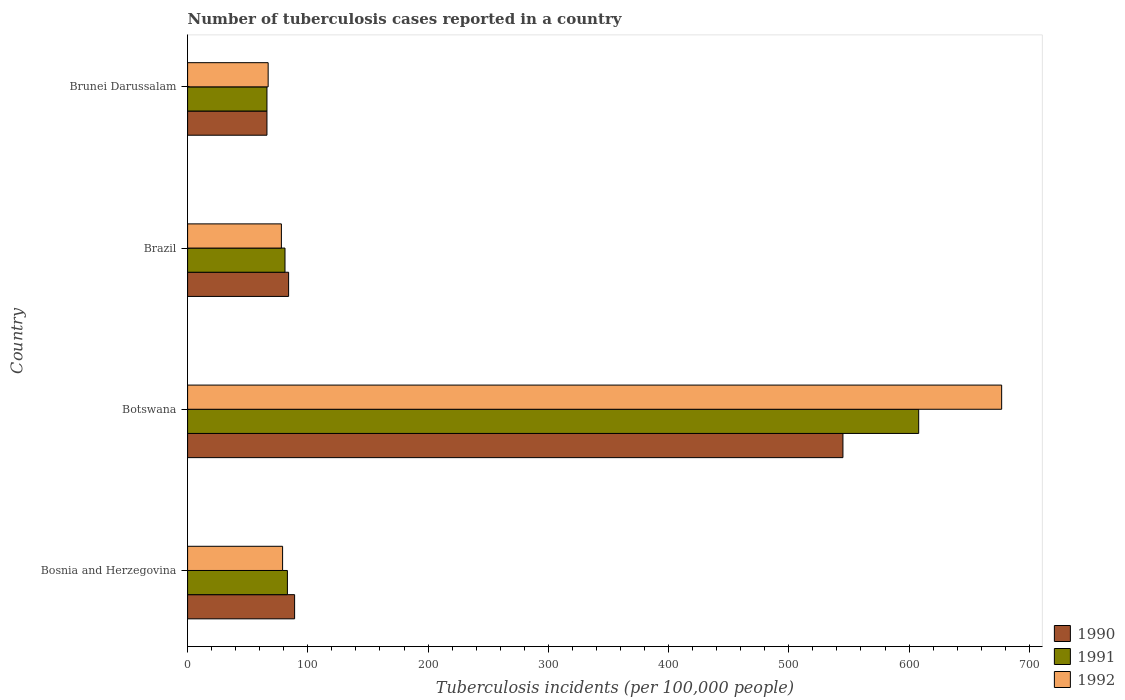How many different coloured bars are there?
Ensure brevity in your answer.  3. How many groups of bars are there?
Your answer should be compact. 4. Are the number of bars per tick equal to the number of legend labels?
Your response must be concise. Yes. Are the number of bars on each tick of the Y-axis equal?
Offer a very short reply. Yes. How many bars are there on the 1st tick from the top?
Offer a very short reply. 3. How many bars are there on the 4th tick from the bottom?
Your response must be concise. 3. What is the label of the 2nd group of bars from the top?
Provide a short and direct response. Brazil. What is the number of tuberculosis cases reported in in 1990 in Botswana?
Your response must be concise. 545. Across all countries, what is the maximum number of tuberculosis cases reported in in 1992?
Ensure brevity in your answer.  677. Across all countries, what is the minimum number of tuberculosis cases reported in in 1990?
Provide a short and direct response. 66. In which country was the number of tuberculosis cases reported in in 1992 maximum?
Your answer should be compact. Botswana. In which country was the number of tuberculosis cases reported in in 1991 minimum?
Your response must be concise. Brunei Darussalam. What is the total number of tuberculosis cases reported in in 1990 in the graph?
Give a very brief answer. 784. What is the average number of tuberculosis cases reported in in 1991 per country?
Provide a succinct answer. 209.5. What is the ratio of the number of tuberculosis cases reported in in 1990 in Botswana to that in Brazil?
Make the answer very short. 6.49. Is the number of tuberculosis cases reported in in 1992 in Bosnia and Herzegovina less than that in Brunei Darussalam?
Your answer should be very brief. No. What is the difference between the highest and the second highest number of tuberculosis cases reported in in 1992?
Ensure brevity in your answer.  598. What is the difference between the highest and the lowest number of tuberculosis cases reported in in 1992?
Keep it short and to the point. 610. What does the 1st bar from the top in Botswana represents?
Provide a short and direct response. 1992. What does the 1st bar from the bottom in Brazil represents?
Your answer should be very brief. 1990. Is it the case that in every country, the sum of the number of tuberculosis cases reported in in 1991 and number of tuberculosis cases reported in in 1990 is greater than the number of tuberculosis cases reported in in 1992?
Make the answer very short. Yes. Are all the bars in the graph horizontal?
Your response must be concise. Yes. How many countries are there in the graph?
Your answer should be compact. 4. Are the values on the major ticks of X-axis written in scientific E-notation?
Offer a terse response. No. Does the graph contain grids?
Provide a short and direct response. No. Where does the legend appear in the graph?
Give a very brief answer. Bottom right. How many legend labels are there?
Provide a succinct answer. 3. What is the title of the graph?
Your answer should be compact. Number of tuberculosis cases reported in a country. What is the label or title of the X-axis?
Ensure brevity in your answer.  Tuberculosis incidents (per 100,0 people). What is the Tuberculosis incidents (per 100,000 people) in 1990 in Bosnia and Herzegovina?
Offer a very short reply. 89. What is the Tuberculosis incidents (per 100,000 people) of 1992 in Bosnia and Herzegovina?
Ensure brevity in your answer.  79. What is the Tuberculosis incidents (per 100,000 people) of 1990 in Botswana?
Make the answer very short. 545. What is the Tuberculosis incidents (per 100,000 people) in 1991 in Botswana?
Your answer should be compact. 608. What is the Tuberculosis incidents (per 100,000 people) in 1992 in Botswana?
Ensure brevity in your answer.  677. What is the Tuberculosis incidents (per 100,000 people) of 1990 in Brazil?
Ensure brevity in your answer.  84. What is the Tuberculosis incidents (per 100,000 people) in 1991 in Brazil?
Offer a terse response. 81. What is the Tuberculosis incidents (per 100,000 people) in 1992 in Brazil?
Your response must be concise. 78. What is the Tuberculosis incidents (per 100,000 people) in 1992 in Brunei Darussalam?
Give a very brief answer. 67. Across all countries, what is the maximum Tuberculosis incidents (per 100,000 people) of 1990?
Keep it short and to the point. 545. Across all countries, what is the maximum Tuberculosis incidents (per 100,000 people) in 1991?
Make the answer very short. 608. Across all countries, what is the maximum Tuberculosis incidents (per 100,000 people) of 1992?
Keep it short and to the point. 677. Across all countries, what is the minimum Tuberculosis incidents (per 100,000 people) of 1990?
Give a very brief answer. 66. Across all countries, what is the minimum Tuberculosis incidents (per 100,000 people) of 1992?
Provide a short and direct response. 67. What is the total Tuberculosis incidents (per 100,000 people) in 1990 in the graph?
Your answer should be compact. 784. What is the total Tuberculosis incidents (per 100,000 people) in 1991 in the graph?
Your response must be concise. 838. What is the total Tuberculosis incidents (per 100,000 people) in 1992 in the graph?
Keep it short and to the point. 901. What is the difference between the Tuberculosis incidents (per 100,000 people) in 1990 in Bosnia and Herzegovina and that in Botswana?
Your answer should be compact. -456. What is the difference between the Tuberculosis incidents (per 100,000 people) of 1991 in Bosnia and Herzegovina and that in Botswana?
Provide a succinct answer. -525. What is the difference between the Tuberculosis incidents (per 100,000 people) in 1992 in Bosnia and Herzegovina and that in Botswana?
Offer a terse response. -598. What is the difference between the Tuberculosis incidents (per 100,000 people) of 1990 in Bosnia and Herzegovina and that in Brazil?
Make the answer very short. 5. What is the difference between the Tuberculosis incidents (per 100,000 people) of 1991 in Bosnia and Herzegovina and that in Brazil?
Provide a succinct answer. 2. What is the difference between the Tuberculosis incidents (per 100,000 people) in 1992 in Bosnia and Herzegovina and that in Brazil?
Offer a very short reply. 1. What is the difference between the Tuberculosis incidents (per 100,000 people) in 1990 in Bosnia and Herzegovina and that in Brunei Darussalam?
Offer a very short reply. 23. What is the difference between the Tuberculosis incidents (per 100,000 people) of 1991 in Bosnia and Herzegovina and that in Brunei Darussalam?
Provide a short and direct response. 17. What is the difference between the Tuberculosis incidents (per 100,000 people) of 1992 in Bosnia and Herzegovina and that in Brunei Darussalam?
Provide a short and direct response. 12. What is the difference between the Tuberculosis incidents (per 100,000 people) in 1990 in Botswana and that in Brazil?
Provide a short and direct response. 461. What is the difference between the Tuberculosis incidents (per 100,000 people) in 1991 in Botswana and that in Brazil?
Provide a short and direct response. 527. What is the difference between the Tuberculosis incidents (per 100,000 people) of 1992 in Botswana and that in Brazil?
Your answer should be compact. 599. What is the difference between the Tuberculosis incidents (per 100,000 people) in 1990 in Botswana and that in Brunei Darussalam?
Your answer should be very brief. 479. What is the difference between the Tuberculosis incidents (per 100,000 people) of 1991 in Botswana and that in Brunei Darussalam?
Your response must be concise. 542. What is the difference between the Tuberculosis incidents (per 100,000 people) of 1992 in Botswana and that in Brunei Darussalam?
Make the answer very short. 610. What is the difference between the Tuberculosis incidents (per 100,000 people) of 1990 in Brazil and that in Brunei Darussalam?
Your answer should be compact. 18. What is the difference between the Tuberculosis incidents (per 100,000 people) in 1991 in Brazil and that in Brunei Darussalam?
Your answer should be very brief. 15. What is the difference between the Tuberculosis incidents (per 100,000 people) in 1990 in Bosnia and Herzegovina and the Tuberculosis incidents (per 100,000 people) in 1991 in Botswana?
Provide a succinct answer. -519. What is the difference between the Tuberculosis incidents (per 100,000 people) of 1990 in Bosnia and Herzegovina and the Tuberculosis incidents (per 100,000 people) of 1992 in Botswana?
Make the answer very short. -588. What is the difference between the Tuberculosis incidents (per 100,000 people) of 1991 in Bosnia and Herzegovina and the Tuberculosis incidents (per 100,000 people) of 1992 in Botswana?
Make the answer very short. -594. What is the difference between the Tuberculosis incidents (per 100,000 people) in 1991 in Bosnia and Herzegovina and the Tuberculosis incidents (per 100,000 people) in 1992 in Brazil?
Make the answer very short. 5. What is the difference between the Tuberculosis incidents (per 100,000 people) in 1990 in Bosnia and Herzegovina and the Tuberculosis incidents (per 100,000 people) in 1991 in Brunei Darussalam?
Make the answer very short. 23. What is the difference between the Tuberculosis incidents (per 100,000 people) of 1990 in Bosnia and Herzegovina and the Tuberculosis incidents (per 100,000 people) of 1992 in Brunei Darussalam?
Your answer should be compact. 22. What is the difference between the Tuberculosis incidents (per 100,000 people) of 1990 in Botswana and the Tuberculosis incidents (per 100,000 people) of 1991 in Brazil?
Offer a terse response. 464. What is the difference between the Tuberculosis incidents (per 100,000 people) of 1990 in Botswana and the Tuberculosis incidents (per 100,000 people) of 1992 in Brazil?
Your answer should be very brief. 467. What is the difference between the Tuberculosis incidents (per 100,000 people) of 1991 in Botswana and the Tuberculosis incidents (per 100,000 people) of 1992 in Brazil?
Keep it short and to the point. 530. What is the difference between the Tuberculosis incidents (per 100,000 people) in 1990 in Botswana and the Tuberculosis incidents (per 100,000 people) in 1991 in Brunei Darussalam?
Your response must be concise. 479. What is the difference between the Tuberculosis incidents (per 100,000 people) in 1990 in Botswana and the Tuberculosis incidents (per 100,000 people) in 1992 in Brunei Darussalam?
Keep it short and to the point. 478. What is the difference between the Tuberculosis incidents (per 100,000 people) in 1991 in Botswana and the Tuberculosis incidents (per 100,000 people) in 1992 in Brunei Darussalam?
Your response must be concise. 541. What is the difference between the Tuberculosis incidents (per 100,000 people) in 1990 in Brazil and the Tuberculosis incidents (per 100,000 people) in 1992 in Brunei Darussalam?
Your answer should be very brief. 17. What is the difference between the Tuberculosis incidents (per 100,000 people) in 1991 in Brazil and the Tuberculosis incidents (per 100,000 people) in 1992 in Brunei Darussalam?
Make the answer very short. 14. What is the average Tuberculosis incidents (per 100,000 people) of 1990 per country?
Your answer should be compact. 196. What is the average Tuberculosis incidents (per 100,000 people) of 1991 per country?
Provide a succinct answer. 209.5. What is the average Tuberculosis incidents (per 100,000 people) of 1992 per country?
Your response must be concise. 225.25. What is the difference between the Tuberculosis incidents (per 100,000 people) of 1990 and Tuberculosis incidents (per 100,000 people) of 1991 in Bosnia and Herzegovina?
Give a very brief answer. 6. What is the difference between the Tuberculosis incidents (per 100,000 people) in 1990 and Tuberculosis incidents (per 100,000 people) in 1992 in Bosnia and Herzegovina?
Provide a succinct answer. 10. What is the difference between the Tuberculosis incidents (per 100,000 people) in 1991 and Tuberculosis incidents (per 100,000 people) in 1992 in Bosnia and Herzegovina?
Your answer should be very brief. 4. What is the difference between the Tuberculosis incidents (per 100,000 people) in 1990 and Tuberculosis incidents (per 100,000 people) in 1991 in Botswana?
Offer a very short reply. -63. What is the difference between the Tuberculosis incidents (per 100,000 people) in 1990 and Tuberculosis incidents (per 100,000 people) in 1992 in Botswana?
Keep it short and to the point. -132. What is the difference between the Tuberculosis incidents (per 100,000 people) in 1991 and Tuberculosis incidents (per 100,000 people) in 1992 in Botswana?
Ensure brevity in your answer.  -69. What is the difference between the Tuberculosis incidents (per 100,000 people) of 1990 and Tuberculosis incidents (per 100,000 people) of 1992 in Brazil?
Your answer should be compact. 6. What is the difference between the Tuberculosis incidents (per 100,000 people) of 1991 and Tuberculosis incidents (per 100,000 people) of 1992 in Brazil?
Make the answer very short. 3. What is the difference between the Tuberculosis incidents (per 100,000 people) of 1991 and Tuberculosis incidents (per 100,000 people) of 1992 in Brunei Darussalam?
Offer a terse response. -1. What is the ratio of the Tuberculosis incidents (per 100,000 people) in 1990 in Bosnia and Herzegovina to that in Botswana?
Your answer should be very brief. 0.16. What is the ratio of the Tuberculosis incidents (per 100,000 people) in 1991 in Bosnia and Herzegovina to that in Botswana?
Keep it short and to the point. 0.14. What is the ratio of the Tuberculosis incidents (per 100,000 people) of 1992 in Bosnia and Herzegovina to that in Botswana?
Ensure brevity in your answer.  0.12. What is the ratio of the Tuberculosis incidents (per 100,000 people) in 1990 in Bosnia and Herzegovina to that in Brazil?
Provide a succinct answer. 1.06. What is the ratio of the Tuberculosis incidents (per 100,000 people) of 1991 in Bosnia and Herzegovina to that in Brazil?
Offer a terse response. 1.02. What is the ratio of the Tuberculosis incidents (per 100,000 people) of 1992 in Bosnia and Herzegovina to that in Brazil?
Keep it short and to the point. 1.01. What is the ratio of the Tuberculosis incidents (per 100,000 people) in 1990 in Bosnia and Herzegovina to that in Brunei Darussalam?
Give a very brief answer. 1.35. What is the ratio of the Tuberculosis incidents (per 100,000 people) of 1991 in Bosnia and Herzegovina to that in Brunei Darussalam?
Offer a very short reply. 1.26. What is the ratio of the Tuberculosis incidents (per 100,000 people) in 1992 in Bosnia and Herzegovina to that in Brunei Darussalam?
Keep it short and to the point. 1.18. What is the ratio of the Tuberculosis incidents (per 100,000 people) in 1990 in Botswana to that in Brazil?
Your response must be concise. 6.49. What is the ratio of the Tuberculosis incidents (per 100,000 people) in 1991 in Botswana to that in Brazil?
Make the answer very short. 7.51. What is the ratio of the Tuberculosis incidents (per 100,000 people) of 1992 in Botswana to that in Brazil?
Make the answer very short. 8.68. What is the ratio of the Tuberculosis incidents (per 100,000 people) of 1990 in Botswana to that in Brunei Darussalam?
Give a very brief answer. 8.26. What is the ratio of the Tuberculosis incidents (per 100,000 people) of 1991 in Botswana to that in Brunei Darussalam?
Ensure brevity in your answer.  9.21. What is the ratio of the Tuberculosis incidents (per 100,000 people) in 1992 in Botswana to that in Brunei Darussalam?
Offer a very short reply. 10.1. What is the ratio of the Tuberculosis incidents (per 100,000 people) of 1990 in Brazil to that in Brunei Darussalam?
Offer a terse response. 1.27. What is the ratio of the Tuberculosis incidents (per 100,000 people) in 1991 in Brazil to that in Brunei Darussalam?
Your answer should be compact. 1.23. What is the ratio of the Tuberculosis incidents (per 100,000 people) of 1992 in Brazil to that in Brunei Darussalam?
Provide a succinct answer. 1.16. What is the difference between the highest and the second highest Tuberculosis incidents (per 100,000 people) of 1990?
Your answer should be very brief. 456. What is the difference between the highest and the second highest Tuberculosis incidents (per 100,000 people) of 1991?
Your response must be concise. 525. What is the difference between the highest and the second highest Tuberculosis incidents (per 100,000 people) of 1992?
Provide a short and direct response. 598. What is the difference between the highest and the lowest Tuberculosis incidents (per 100,000 people) of 1990?
Your answer should be compact. 479. What is the difference between the highest and the lowest Tuberculosis incidents (per 100,000 people) in 1991?
Provide a succinct answer. 542. What is the difference between the highest and the lowest Tuberculosis incidents (per 100,000 people) of 1992?
Offer a very short reply. 610. 